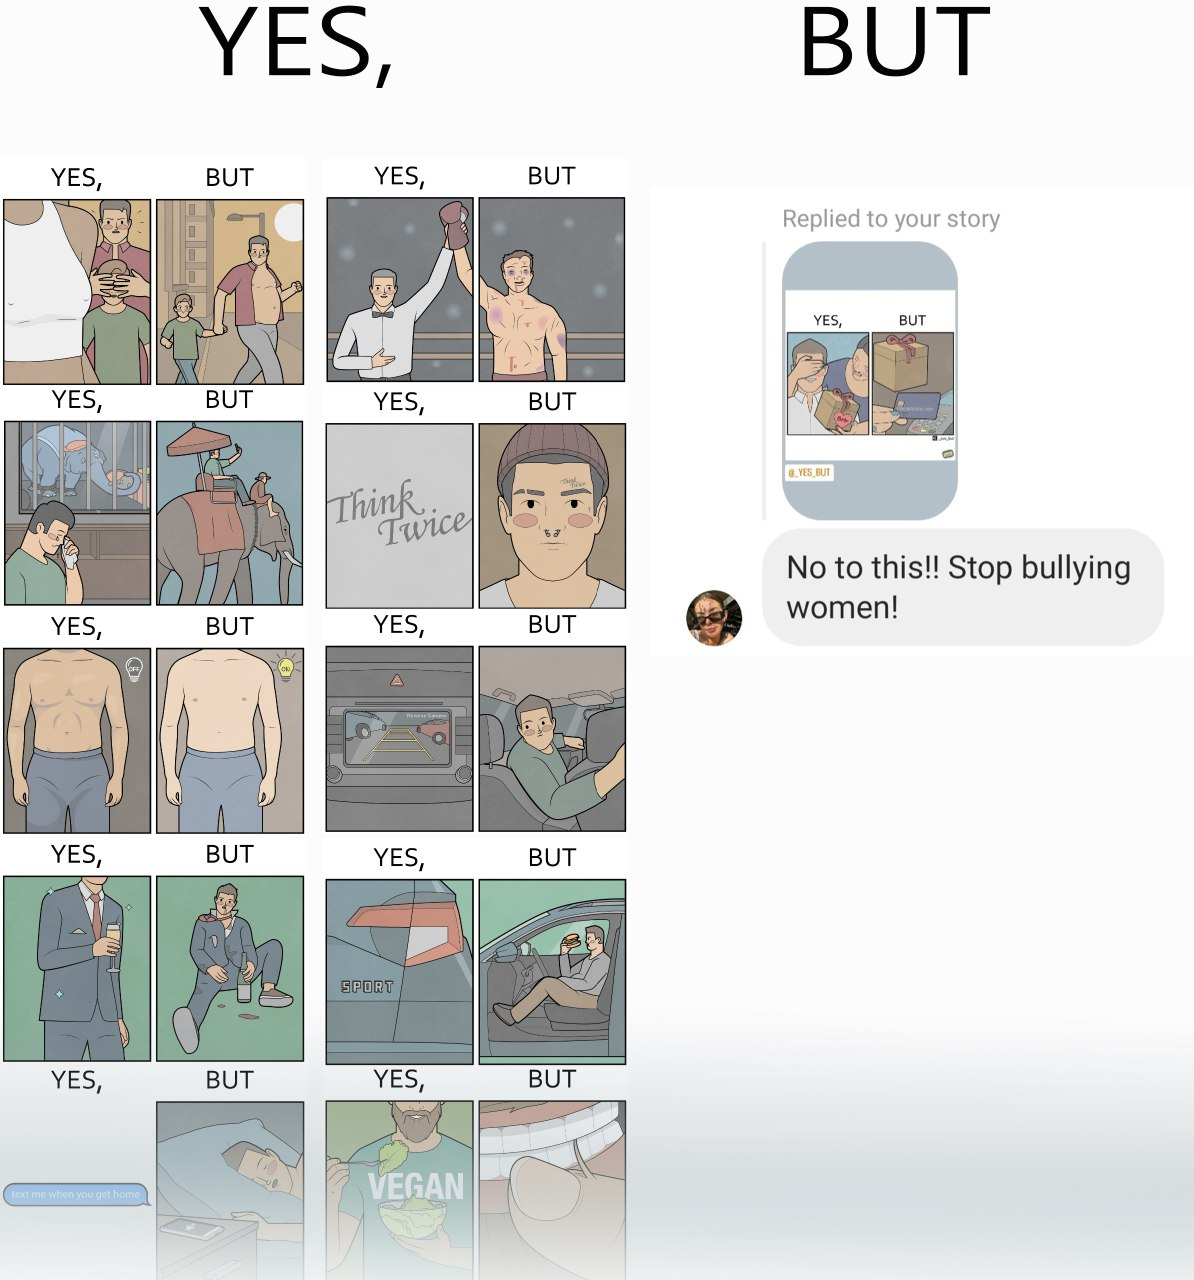What does this image depict? The image is ironic, because in the first image there are many memes on men but in the second image a person is seen raising voice over some meme on woman and calling it as woman bully but no one raises their voice against memes over man calling them as man bully 